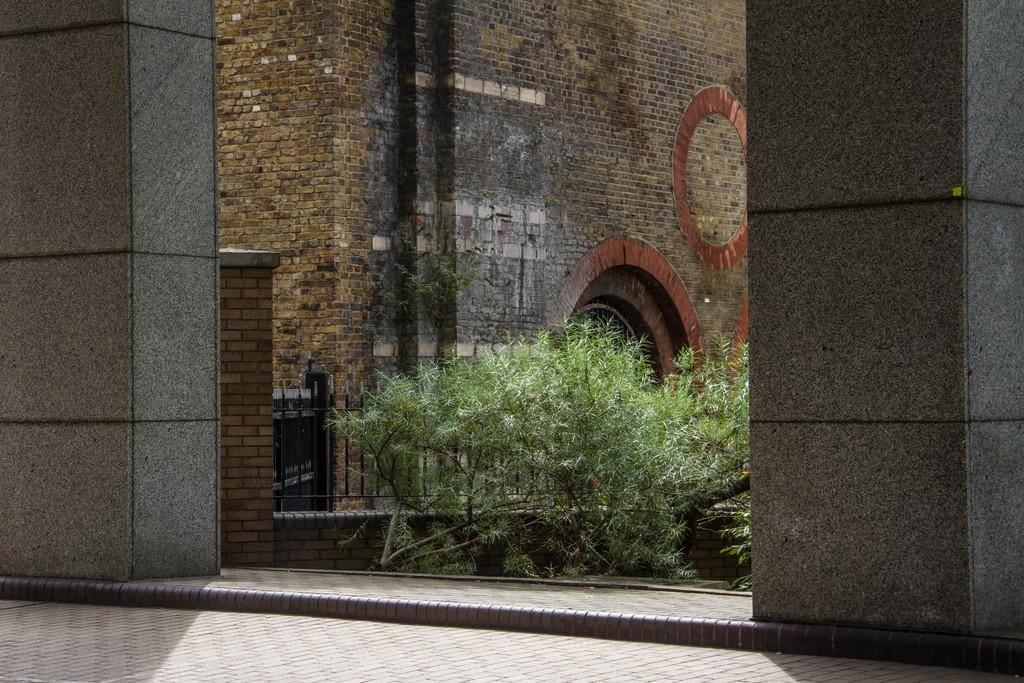What type of structure is visible in the image? There is a building in the image. What can be seen in front of the building? There are trees in front of the building. What type of barrier is present in the image? There is an iron railing in the image. What architectural feature can be seen on the building? There are pillars in the image. What type of business is being conducted by the fireman in the image? There is no fireman present in the image, so it is not possible to answer that question. 